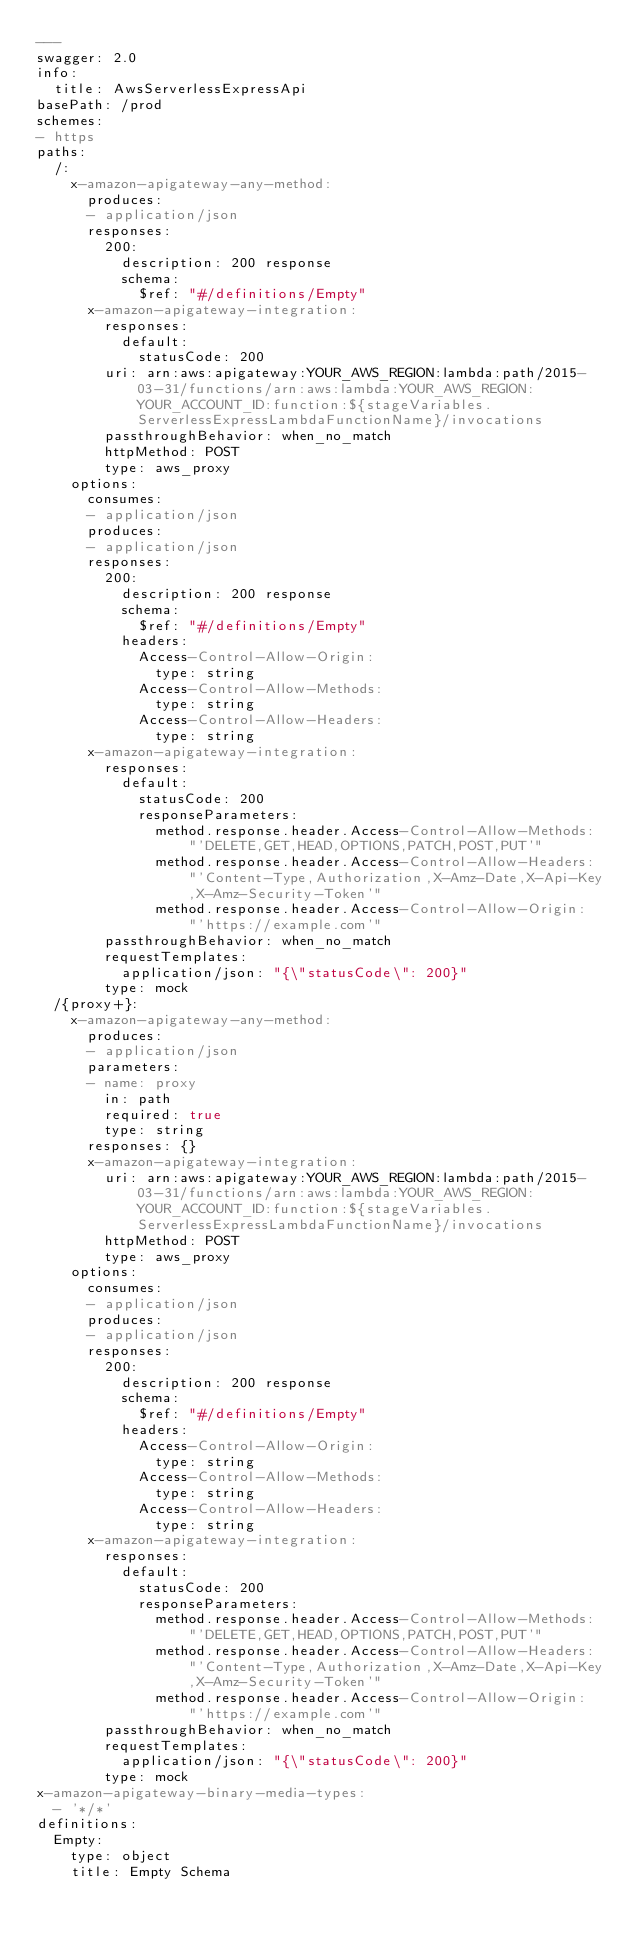<code> <loc_0><loc_0><loc_500><loc_500><_YAML_>---
swagger: 2.0
info:
  title: AwsServerlessExpressApi
basePath: /prod
schemes:
- https
paths:
  /:
    x-amazon-apigateway-any-method:
      produces:
      - application/json
      responses:
        200:
          description: 200 response
          schema:
            $ref: "#/definitions/Empty"
      x-amazon-apigateway-integration:
        responses:
          default:
            statusCode: 200
        uri: arn:aws:apigateway:YOUR_AWS_REGION:lambda:path/2015-03-31/functions/arn:aws:lambda:YOUR_AWS_REGION:YOUR_ACCOUNT_ID:function:${stageVariables.ServerlessExpressLambdaFunctionName}/invocations
        passthroughBehavior: when_no_match
        httpMethod: POST
        type: aws_proxy
    options:
      consumes:
      - application/json
      produces:
      - application/json
      responses:
        200:
          description: 200 response
          schema:
            $ref: "#/definitions/Empty"
          headers:
            Access-Control-Allow-Origin:
              type: string
            Access-Control-Allow-Methods:
              type: string
            Access-Control-Allow-Headers:
              type: string
      x-amazon-apigateway-integration:
        responses:
          default:
            statusCode: 200
            responseParameters:
              method.response.header.Access-Control-Allow-Methods: "'DELETE,GET,HEAD,OPTIONS,PATCH,POST,PUT'"
              method.response.header.Access-Control-Allow-Headers: "'Content-Type,Authorization,X-Amz-Date,X-Api-Key,X-Amz-Security-Token'"
              method.response.header.Access-Control-Allow-Origin: "'https://example.com'"
        passthroughBehavior: when_no_match
        requestTemplates:
          application/json: "{\"statusCode\": 200}"
        type: mock
  /{proxy+}:
    x-amazon-apigateway-any-method:
      produces:
      - application/json
      parameters:
      - name: proxy
        in: path
        required: true
        type: string
      responses: {}
      x-amazon-apigateway-integration:
        uri: arn:aws:apigateway:YOUR_AWS_REGION:lambda:path/2015-03-31/functions/arn:aws:lambda:YOUR_AWS_REGION:YOUR_ACCOUNT_ID:function:${stageVariables.ServerlessExpressLambdaFunctionName}/invocations
        httpMethod: POST
        type: aws_proxy
    options:
      consumes:
      - application/json
      produces:
      - application/json
      responses:
        200:
          description: 200 response
          schema:
            $ref: "#/definitions/Empty"
          headers:
            Access-Control-Allow-Origin:
              type: string
            Access-Control-Allow-Methods:
              type: string
            Access-Control-Allow-Headers:
              type: string
      x-amazon-apigateway-integration:
        responses:
          default:
            statusCode: 200
            responseParameters:
              method.response.header.Access-Control-Allow-Methods: "'DELETE,GET,HEAD,OPTIONS,PATCH,POST,PUT'"
              method.response.header.Access-Control-Allow-Headers: "'Content-Type,Authorization,X-Amz-Date,X-Api-Key,X-Amz-Security-Token'"
              method.response.header.Access-Control-Allow-Origin: "'https://example.com'"
        passthroughBehavior: when_no_match
        requestTemplates:
          application/json: "{\"statusCode\": 200}"
        type: mock
x-amazon-apigateway-binary-media-types:
  - '*/*'
definitions:
  Empty:
    type: object
    title: Empty Schema
</code> 